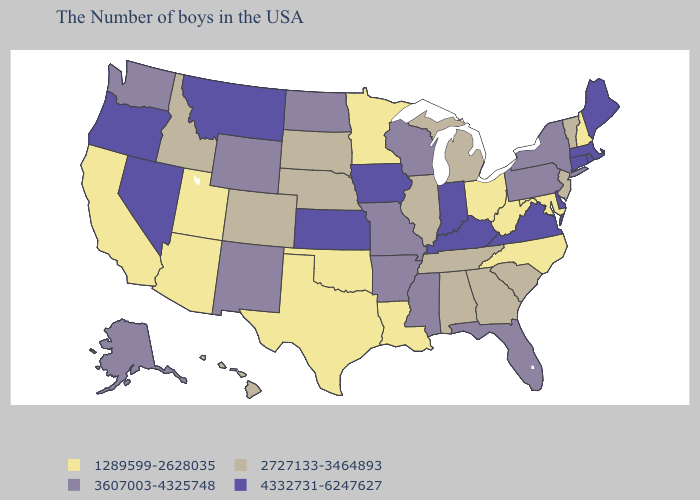Name the states that have a value in the range 1289599-2628035?
Be succinct. New Hampshire, Maryland, North Carolina, West Virginia, Ohio, Louisiana, Minnesota, Oklahoma, Texas, Utah, Arizona, California. Does Kansas have the lowest value in the MidWest?
Answer briefly. No. Name the states that have a value in the range 4332731-6247627?
Give a very brief answer. Maine, Massachusetts, Rhode Island, Connecticut, Delaware, Virginia, Kentucky, Indiana, Iowa, Kansas, Montana, Nevada, Oregon. How many symbols are there in the legend?
Write a very short answer. 4. What is the value of Illinois?
Answer briefly. 2727133-3464893. Is the legend a continuous bar?
Concise answer only. No. Which states have the lowest value in the USA?
Keep it brief. New Hampshire, Maryland, North Carolina, West Virginia, Ohio, Louisiana, Minnesota, Oklahoma, Texas, Utah, Arizona, California. Name the states that have a value in the range 4332731-6247627?
Keep it brief. Maine, Massachusetts, Rhode Island, Connecticut, Delaware, Virginia, Kentucky, Indiana, Iowa, Kansas, Montana, Nevada, Oregon. Name the states that have a value in the range 3607003-4325748?
Keep it brief. New York, Pennsylvania, Florida, Wisconsin, Mississippi, Missouri, Arkansas, North Dakota, Wyoming, New Mexico, Washington, Alaska. Does Maryland have the same value as Nebraska?
Answer briefly. No. What is the highest value in the USA?
Short answer required. 4332731-6247627. What is the value of Massachusetts?
Be succinct. 4332731-6247627. What is the value of New York?
Keep it brief. 3607003-4325748. Which states have the lowest value in the USA?
Answer briefly. New Hampshire, Maryland, North Carolina, West Virginia, Ohio, Louisiana, Minnesota, Oklahoma, Texas, Utah, Arizona, California. 